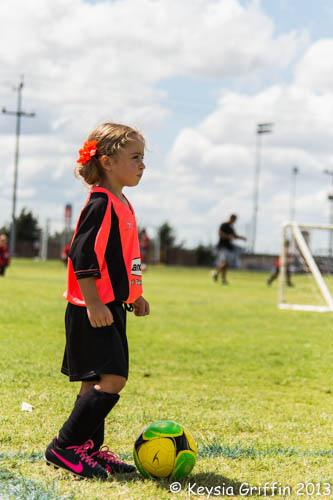What kind of poles stand erect in the background? Please explain your reasoning. electric. The crossed poles hold up electrical wires. 